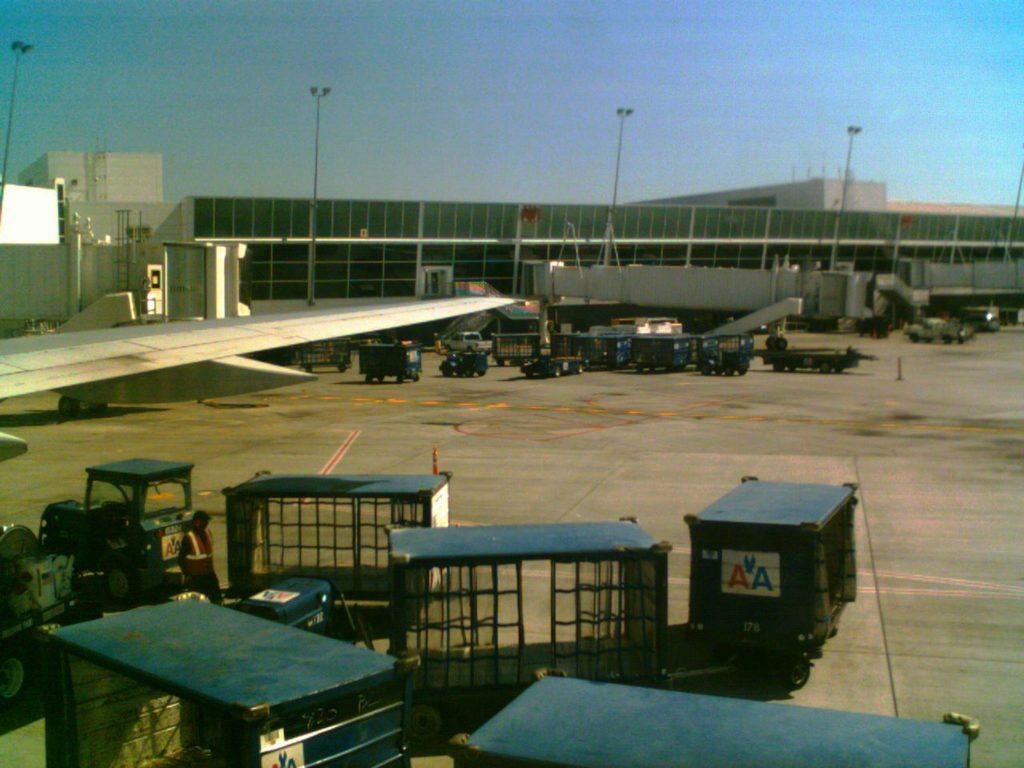Provide a one-sentence caption for the provided image. Luggage cards with the logo AA are being driven past an airplane at the airport. 